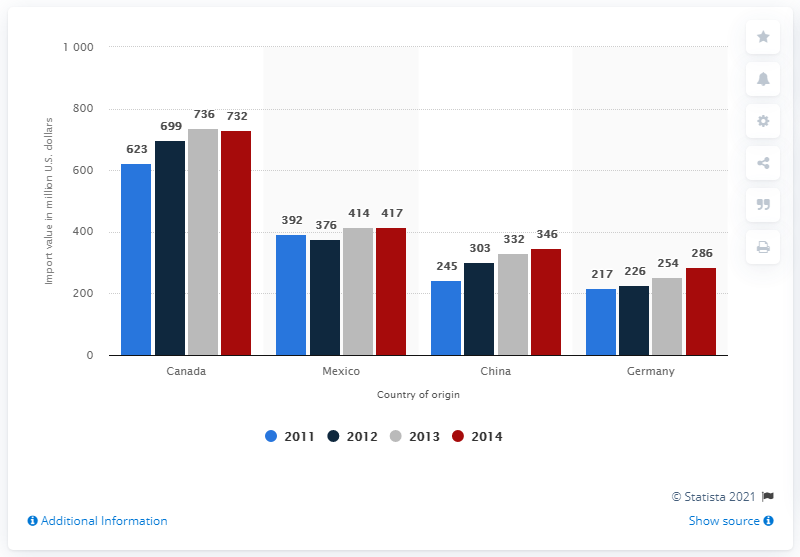Specify some key components in this picture. In 2014, the value of US soap and cleaning product imports from Canada was 736 million dollars. 